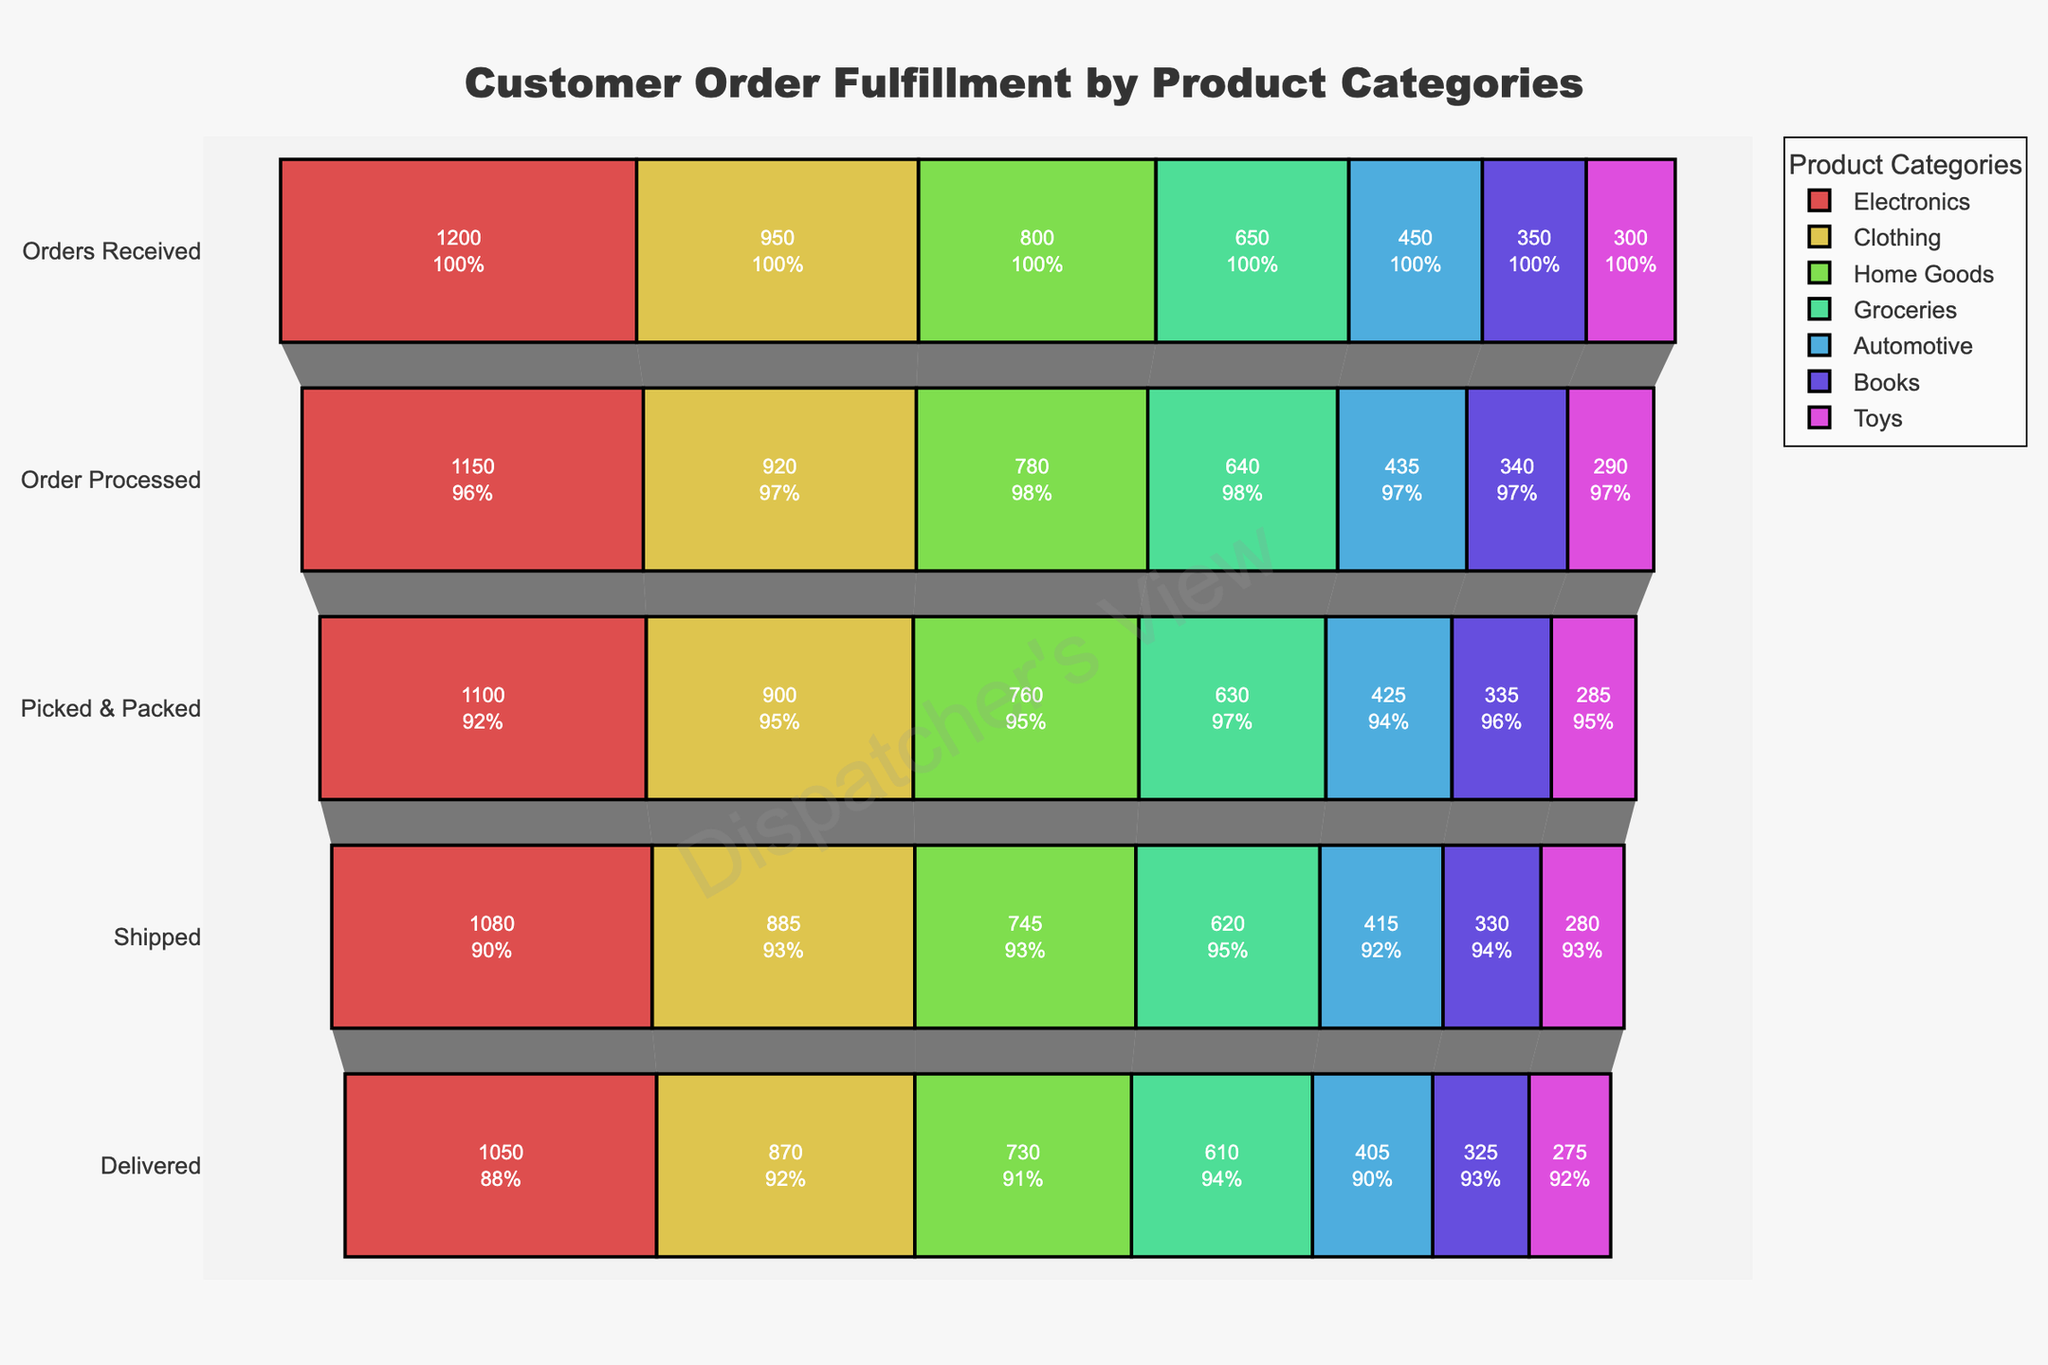what is the title of the figure? The title is located at the top of the figure and it provides a description of what the chart represents.
Answer: Customer Order Fulfillment by Product Categories what color is used to represent the Electronics category? The Electronics category is represented by multiple similar hues of a color. Each stage has a specific shade. For example, the first shade of Electronics is a hue with 70% lightness and 80% opacity.
Answer: shades of a similar hue which category has the fewest orders delivered? To determine this, we look at the final stage 'Delivered' and compare the values for each category.
Answer: Toys how many stages are there in the funnel chart? The number of stages is determined by counting the distinct segments in the funnel for each category.
Answer: 5 compare the number of orders processed for Electronics and Groceries. which has more? Look at the 'Order Processed' stage for both Electronics and Groceries and compare the values.
Answer: Electronics which category has the highest drop-off rate between 'Orders Received' and 'Order Processed'? To determine the highest drop-off rate, calculate the difference between 'Orders Received' and 'Order Processed' for each category and find the maximum relative drop.
Answer: Automotive with 3.33% drop (450 - 435) / 450 how do the delivered orders of Home Goods compare to those of Books? Compare the 'Delivered' stage values for Home Goods and Books.
Answer: Home Goods has more delivered orders 